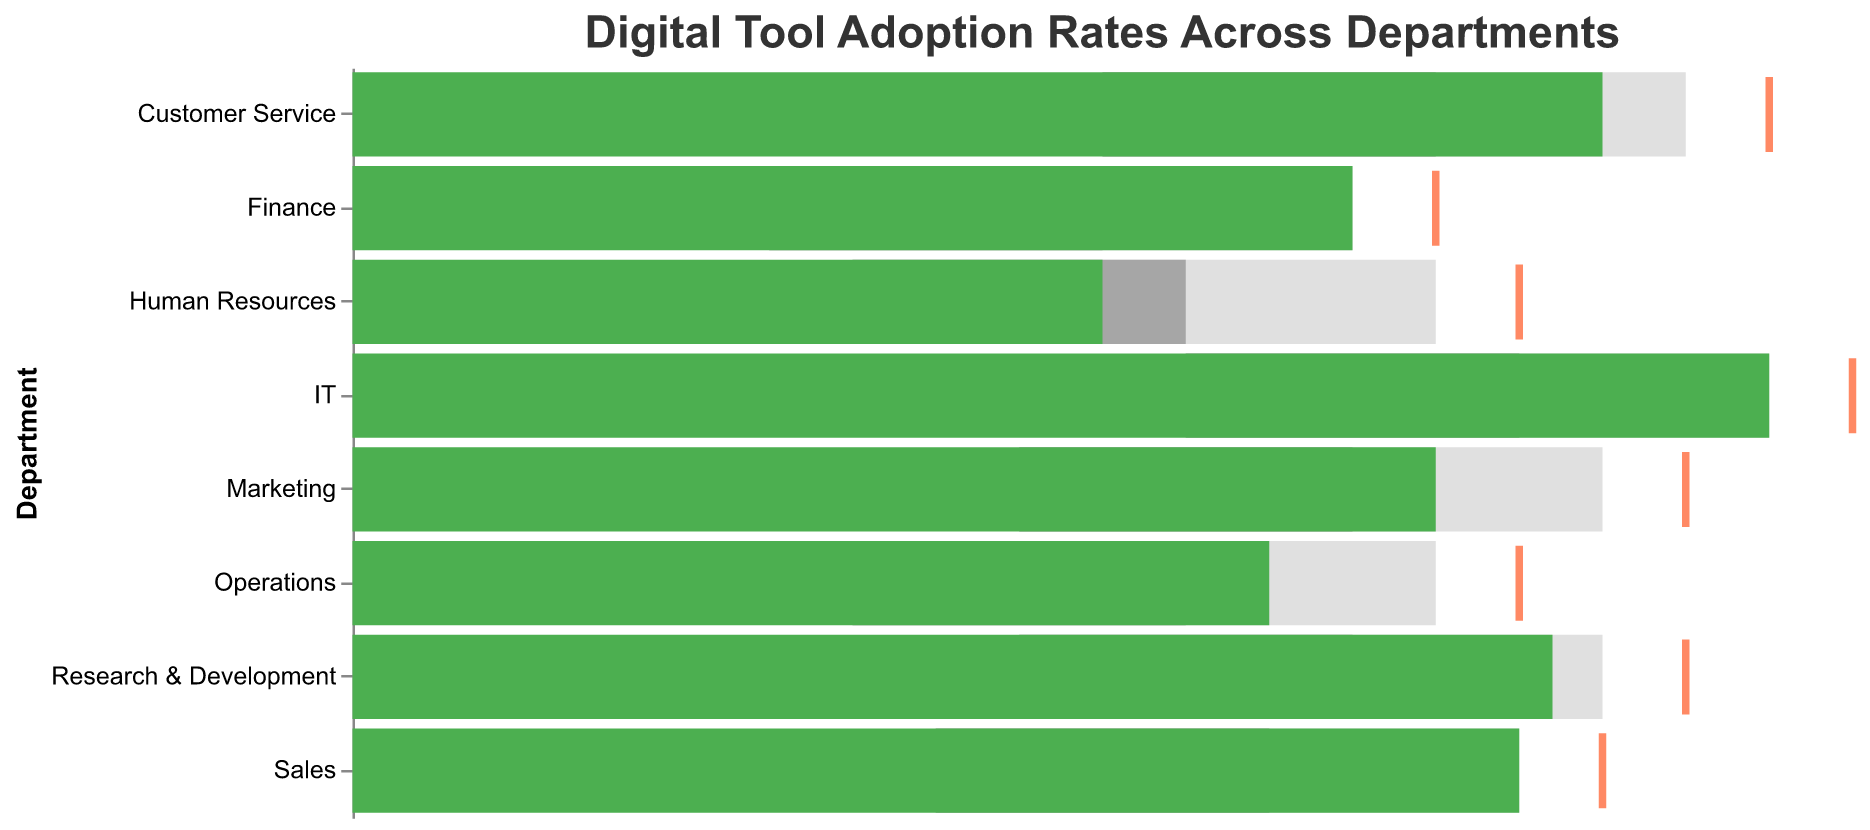What's the title of the plot? The title of the plot can be found at the top. It reads "Digital Tool Adoption Rates Across Departments".
Answer: Digital Tool Adoption Rates Across Departments How many departments are represented in the plot? Count the number of unique department names on the y-axis. There are 8 departments listed.
Answer: 8 Which department has the highest actual adoption rate? Look for the green bar that extends furthest to the right. IT has the highest actual adoption rate of 85.
Answer: IT What is the target adoption rate for the Customer Service department? Find the orange tick mark corresponding to Customer Service on the y-axis, and its position on the x-axis is 85.
Answer: 85 Which department's actual adoption rate is closest to its target rate? Compare the length of the green bars to the position of the orange tick marks. IT’s actual adoption rate (85) is closest to its target (90), with a difference of 5.
Answer: IT How many departments have an actual adoption rate that falls within the "Satisfactory" range for their respective categories? Count the green bars that are within the grey "Satisfactory" range. Sales, Finance, Customer Service, Operations, and Research & Development fall within this range, making a total of 5 departments.
Answer: 5 Which department has the largest gap between its actual and target adoption rate? Subtract the actual adoption rate from the target rate for each department and find the largest difference. Human Resources has the largest gap with a target of 70 and an actual of 45 (a difference of 25).
Answer: Human Resources Compare the actual adoption rates of Marketing and Sales. Which department has a higher rate, and by how much? Compare the lengths of the green bars for Marketing and Sales. Marketing has an actual rate of 65, and Sales has 70, making Sales higher by 5.
Answer: Sales by 5 What range do the poor adoption rates cover for the Finance department? The "Poor" range is denoted by the beginning of the first grey bar and extends to the next tonal change, which is from 25 to 45 for Finance.
Answer: 25 to 45 